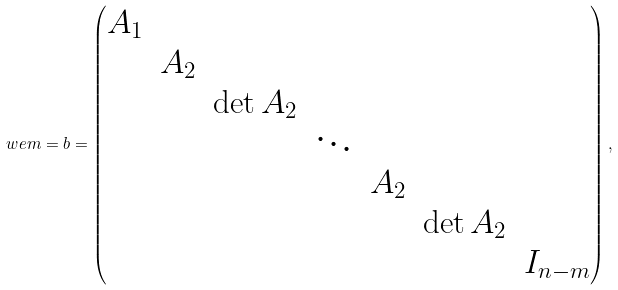Convert formula to latex. <formula><loc_0><loc_0><loc_500><loc_500>\ w e m = b = \begin{pmatrix} A _ { 1 } & & & & & & \\ & A _ { 2 } & & & & & \\ & & \det A _ { 2 } & & & & \\ & & & \ddots & & & \\ & & & & A _ { 2 } & & \\ & & & & & \det A _ { 2 } & \\ & & & & & & I _ { n - m } \end{pmatrix} ,</formula> 